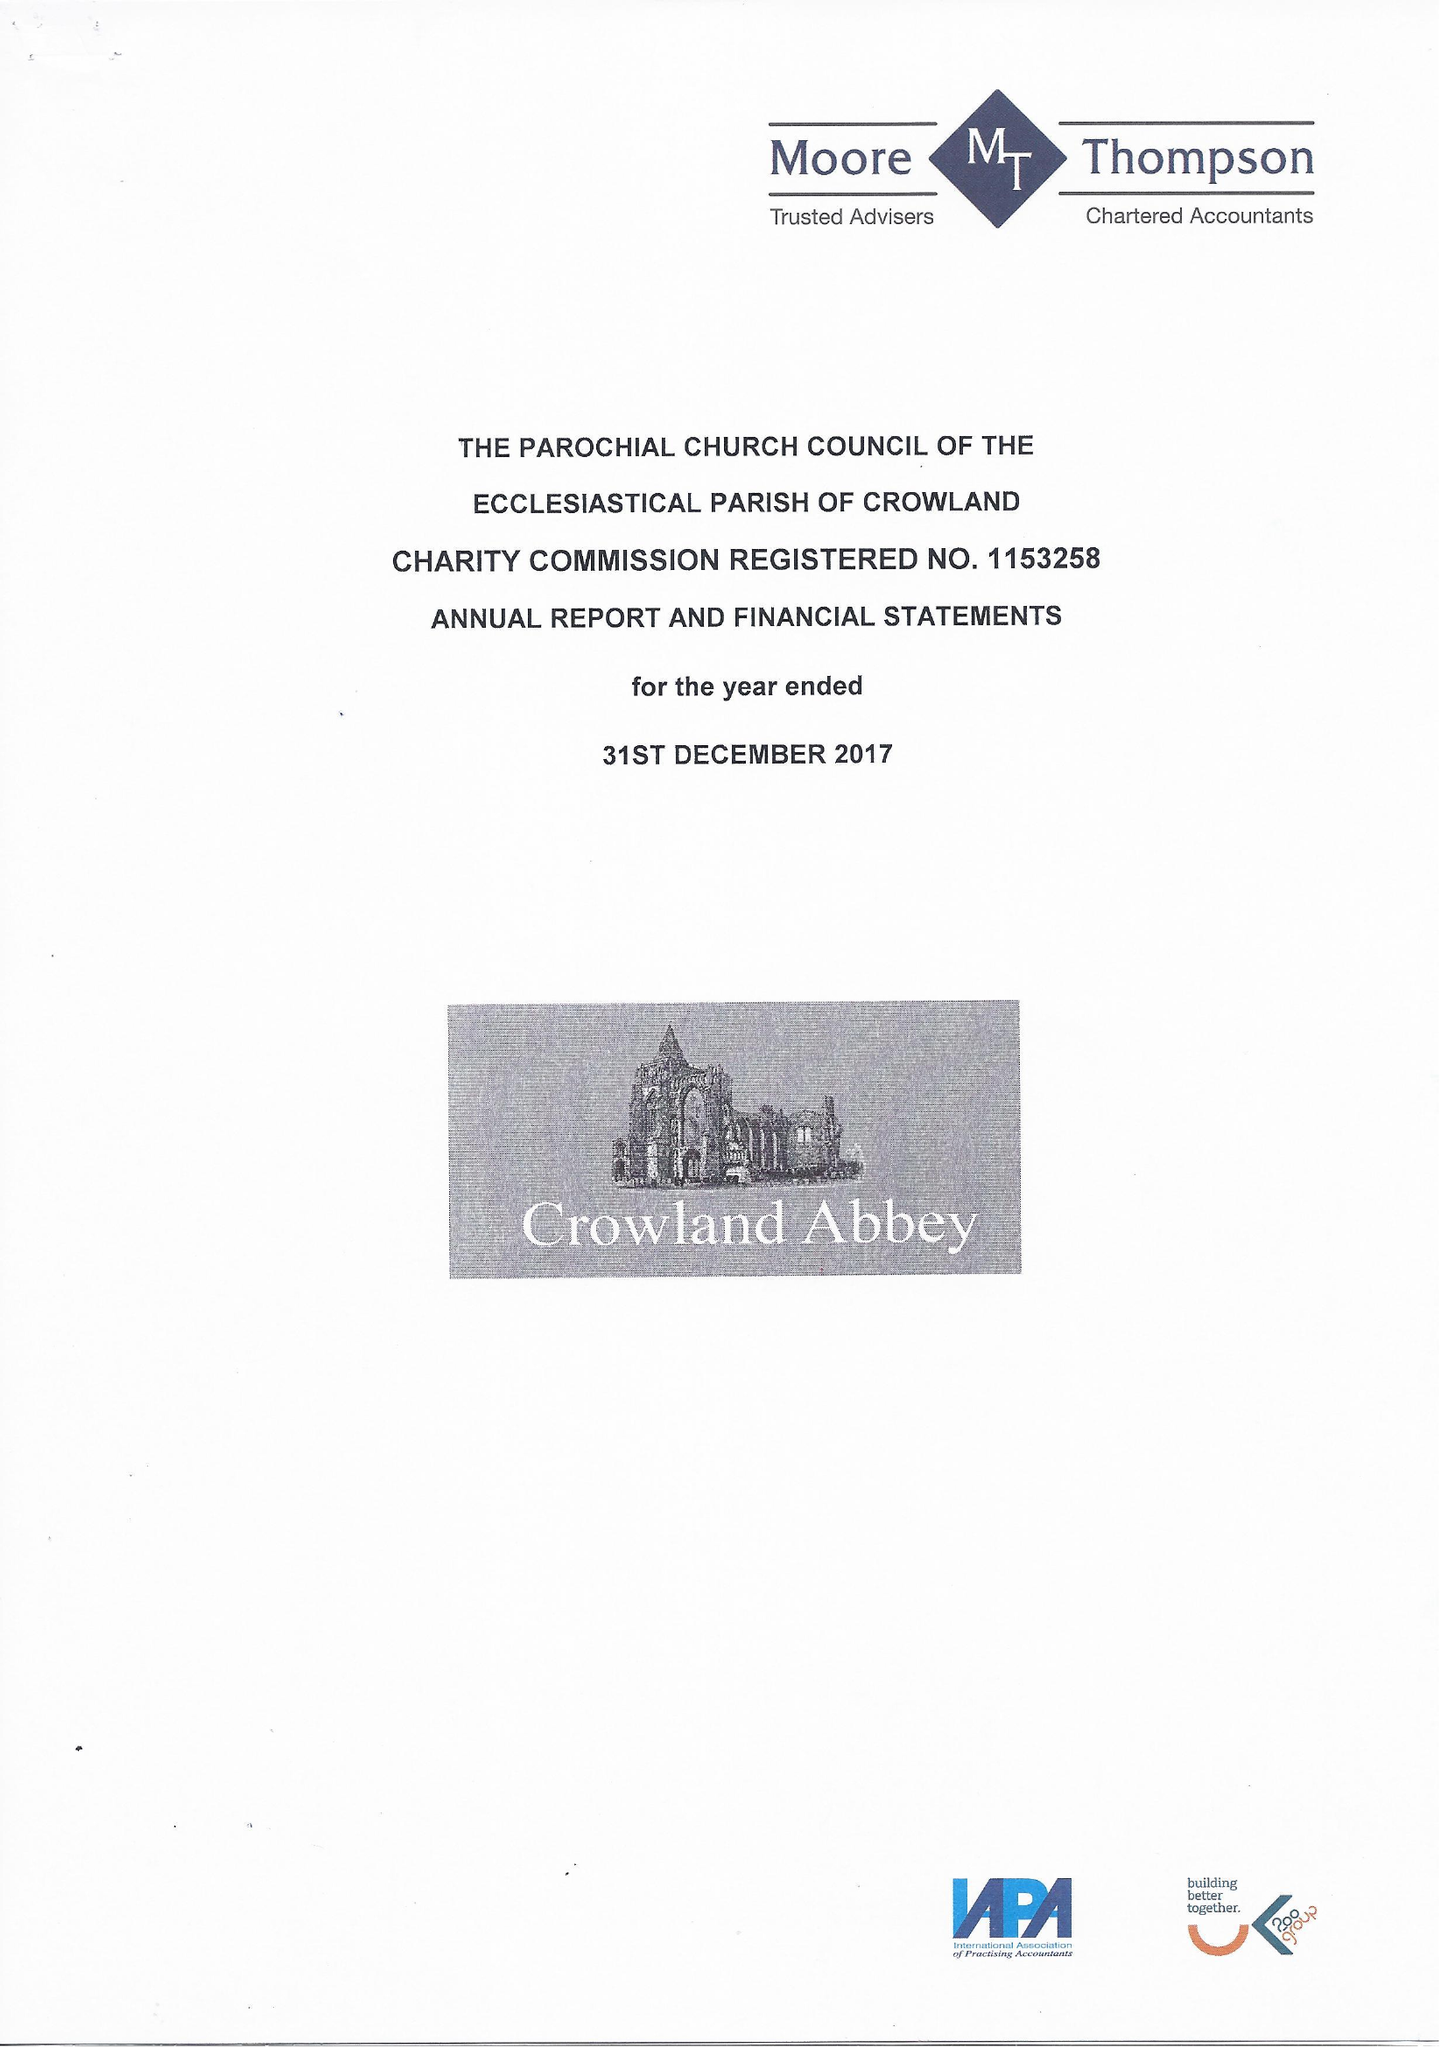What is the value for the address__post_town?
Answer the question using a single word or phrase. PETERBOROUGH 